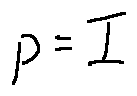Convert formula to latex. <formula><loc_0><loc_0><loc_500><loc_500>p = I</formula> 